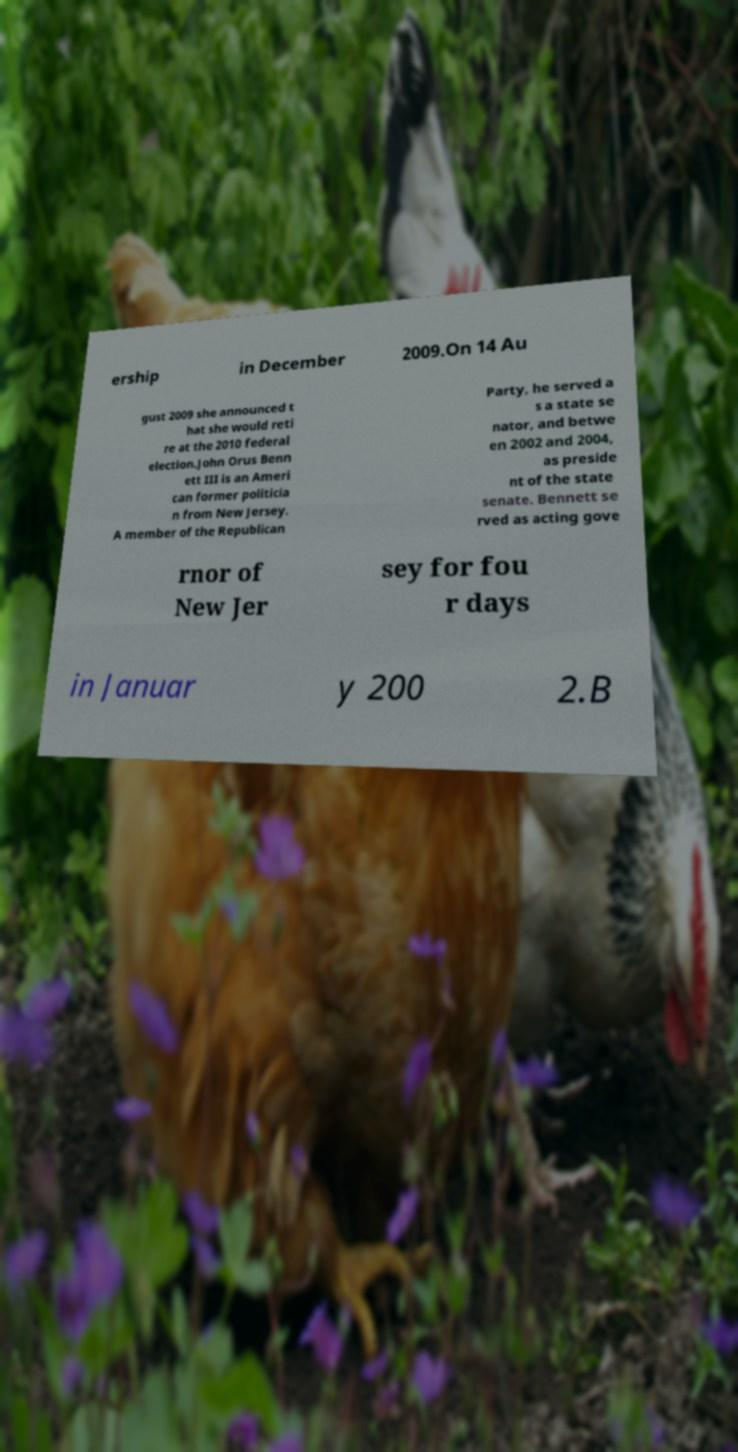For documentation purposes, I need the text within this image transcribed. Could you provide that? ership in December 2009.On 14 Au gust 2009 she announced t hat she would reti re at the 2010 federal election.John Orus Benn ett III is an Ameri can former politicia n from New Jersey. A member of the Republican Party, he served a s a state se nator, and betwe en 2002 and 2004, as preside nt of the state senate. Bennett se rved as acting gove rnor of New Jer sey for fou r days in Januar y 200 2.B 